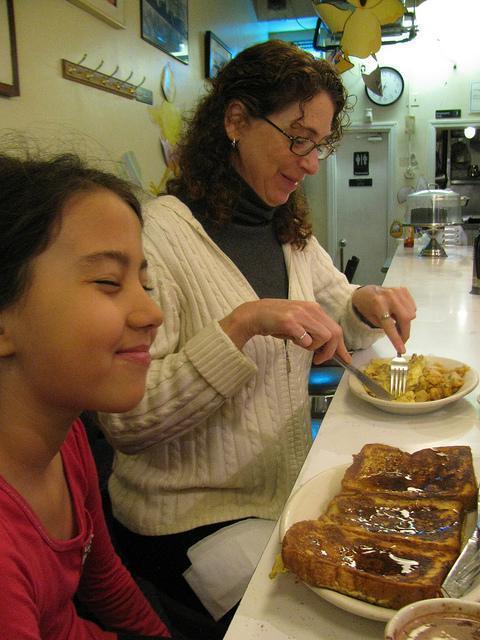How many people are in the photo?
Give a very brief answer. 2. How many bowls are in the photo?
Give a very brief answer. 2. 